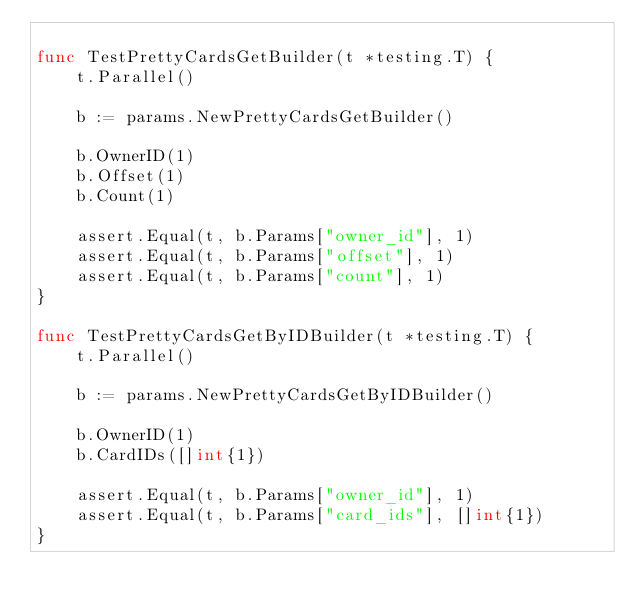Convert code to text. <code><loc_0><loc_0><loc_500><loc_500><_Go_>
func TestPrettyCardsGetBuilder(t *testing.T) {
	t.Parallel()

	b := params.NewPrettyCardsGetBuilder()

	b.OwnerID(1)
	b.Offset(1)
	b.Count(1)

	assert.Equal(t, b.Params["owner_id"], 1)
	assert.Equal(t, b.Params["offset"], 1)
	assert.Equal(t, b.Params["count"], 1)
}

func TestPrettyCardsGetByIDBuilder(t *testing.T) {
	t.Parallel()

	b := params.NewPrettyCardsGetByIDBuilder()

	b.OwnerID(1)
	b.CardIDs([]int{1})

	assert.Equal(t, b.Params["owner_id"], 1)
	assert.Equal(t, b.Params["card_ids"], []int{1})
}
</code> 